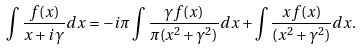<formula> <loc_0><loc_0><loc_500><loc_500>\int \frac { f ( x ) } { x + i \gamma } d x = - i \pi \int \frac { \gamma f ( x ) } { \pi ( x ^ { 2 } + \gamma ^ { 2 } ) } d x + \int \frac { x f ( x ) } { ( x ^ { 2 } + \gamma ^ { 2 } ) } d x .</formula> 